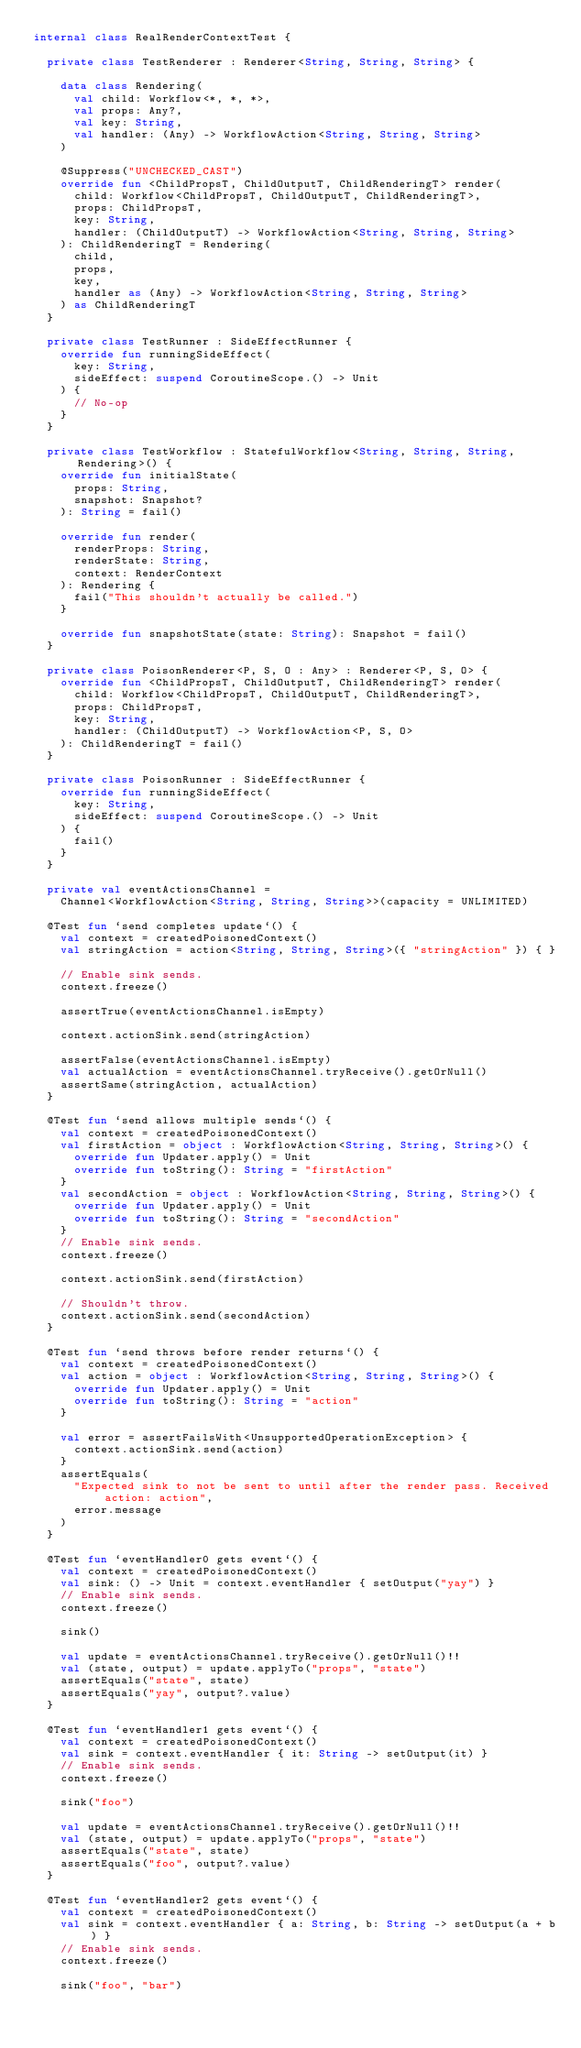Convert code to text. <code><loc_0><loc_0><loc_500><loc_500><_Kotlin_>internal class RealRenderContextTest {

  private class TestRenderer : Renderer<String, String, String> {

    data class Rendering(
      val child: Workflow<*, *, *>,
      val props: Any?,
      val key: String,
      val handler: (Any) -> WorkflowAction<String, String, String>
    )

    @Suppress("UNCHECKED_CAST")
    override fun <ChildPropsT, ChildOutputT, ChildRenderingT> render(
      child: Workflow<ChildPropsT, ChildOutputT, ChildRenderingT>,
      props: ChildPropsT,
      key: String,
      handler: (ChildOutputT) -> WorkflowAction<String, String, String>
    ): ChildRenderingT = Rendering(
      child,
      props,
      key,
      handler as (Any) -> WorkflowAction<String, String, String>
    ) as ChildRenderingT
  }

  private class TestRunner : SideEffectRunner {
    override fun runningSideEffect(
      key: String,
      sideEffect: suspend CoroutineScope.() -> Unit
    ) {
      // No-op
    }
  }

  private class TestWorkflow : StatefulWorkflow<String, String, String, Rendering>() {
    override fun initialState(
      props: String,
      snapshot: Snapshot?
    ): String = fail()

    override fun render(
      renderProps: String,
      renderState: String,
      context: RenderContext
    ): Rendering {
      fail("This shouldn't actually be called.")
    }

    override fun snapshotState(state: String): Snapshot = fail()
  }

  private class PoisonRenderer<P, S, O : Any> : Renderer<P, S, O> {
    override fun <ChildPropsT, ChildOutputT, ChildRenderingT> render(
      child: Workflow<ChildPropsT, ChildOutputT, ChildRenderingT>,
      props: ChildPropsT,
      key: String,
      handler: (ChildOutputT) -> WorkflowAction<P, S, O>
    ): ChildRenderingT = fail()
  }

  private class PoisonRunner : SideEffectRunner {
    override fun runningSideEffect(
      key: String,
      sideEffect: suspend CoroutineScope.() -> Unit
    ) {
      fail()
    }
  }

  private val eventActionsChannel =
    Channel<WorkflowAction<String, String, String>>(capacity = UNLIMITED)

  @Test fun `send completes update`() {
    val context = createdPoisonedContext()
    val stringAction = action<String, String, String>({ "stringAction" }) { }

    // Enable sink sends.
    context.freeze()

    assertTrue(eventActionsChannel.isEmpty)

    context.actionSink.send(stringAction)

    assertFalse(eventActionsChannel.isEmpty)
    val actualAction = eventActionsChannel.tryReceive().getOrNull()
    assertSame(stringAction, actualAction)
  }

  @Test fun `send allows multiple sends`() {
    val context = createdPoisonedContext()
    val firstAction = object : WorkflowAction<String, String, String>() {
      override fun Updater.apply() = Unit
      override fun toString(): String = "firstAction"
    }
    val secondAction = object : WorkflowAction<String, String, String>() {
      override fun Updater.apply() = Unit
      override fun toString(): String = "secondAction"
    }
    // Enable sink sends.
    context.freeze()

    context.actionSink.send(firstAction)

    // Shouldn't throw.
    context.actionSink.send(secondAction)
  }

  @Test fun `send throws before render returns`() {
    val context = createdPoisonedContext()
    val action = object : WorkflowAction<String, String, String>() {
      override fun Updater.apply() = Unit
      override fun toString(): String = "action"
    }

    val error = assertFailsWith<UnsupportedOperationException> {
      context.actionSink.send(action)
    }
    assertEquals(
      "Expected sink to not be sent to until after the render pass. Received action: action",
      error.message
    )
  }

  @Test fun `eventHandler0 gets event`() {
    val context = createdPoisonedContext()
    val sink: () -> Unit = context.eventHandler { setOutput("yay") }
    // Enable sink sends.
    context.freeze()

    sink()

    val update = eventActionsChannel.tryReceive().getOrNull()!!
    val (state, output) = update.applyTo("props", "state")
    assertEquals("state", state)
    assertEquals("yay", output?.value)
  }

  @Test fun `eventHandler1 gets event`() {
    val context = createdPoisonedContext()
    val sink = context.eventHandler { it: String -> setOutput(it) }
    // Enable sink sends.
    context.freeze()

    sink("foo")

    val update = eventActionsChannel.tryReceive().getOrNull()!!
    val (state, output) = update.applyTo("props", "state")
    assertEquals("state", state)
    assertEquals("foo", output?.value)
  }

  @Test fun `eventHandler2 gets event`() {
    val context = createdPoisonedContext()
    val sink = context.eventHandler { a: String, b: String -> setOutput(a + b) }
    // Enable sink sends.
    context.freeze()

    sink("foo", "bar")
</code> 